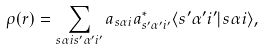<formula> <loc_0><loc_0><loc_500><loc_500>\rho ( r ) = \sum _ { s \alpha i s ^ { \prime } \alpha ^ { \prime } i ^ { \prime } } a _ { s \alpha i } a _ { s ^ { \prime } \alpha ^ { \prime } i ^ { \prime } } ^ { * } \langle s ^ { \prime } \alpha ^ { \prime } i ^ { \prime } | s \alpha i \rangle ,</formula> 